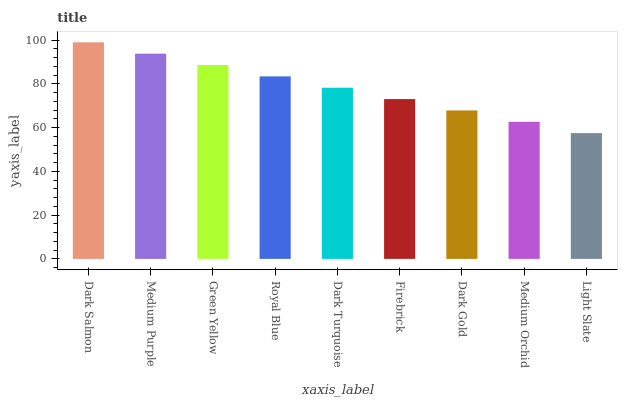Is Light Slate the minimum?
Answer yes or no. Yes. Is Dark Salmon the maximum?
Answer yes or no. Yes. Is Medium Purple the minimum?
Answer yes or no. No. Is Medium Purple the maximum?
Answer yes or no. No. Is Dark Salmon greater than Medium Purple?
Answer yes or no. Yes. Is Medium Purple less than Dark Salmon?
Answer yes or no. Yes. Is Medium Purple greater than Dark Salmon?
Answer yes or no. No. Is Dark Salmon less than Medium Purple?
Answer yes or no. No. Is Dark Turquoise the high median?
Answer yes or no. Yes. Is Dark Turquoise the low median?
Answer yes or no. Yes. Is Dark Gold the high median?
Answer yes or no. No. Is Royal Blue the low median?
Answer yes or no. No. 